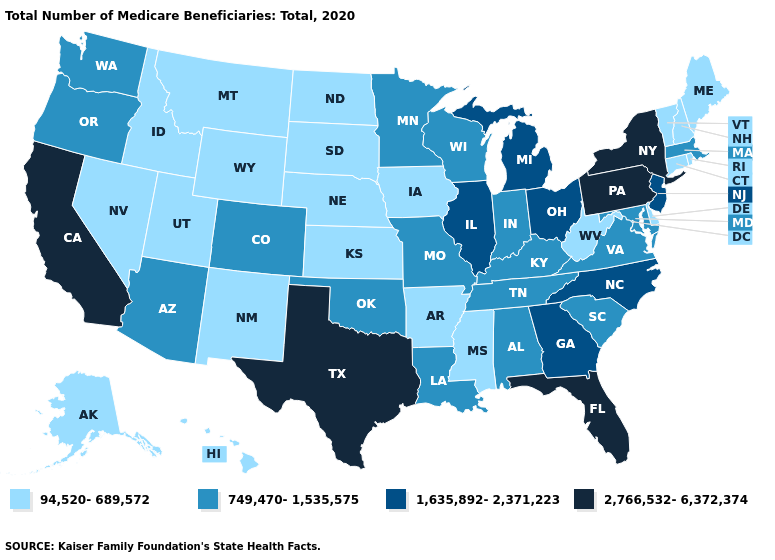What is the value of Arizona?
Quick response, please. 749,470-1,535,575. What is the lowest value in the Northeast?
Be succinct. 94,520-689,572. What is the value of Kentucky?
Short answer required. 749,470-1,535,575. What is the value of North Carolina?
Give a very brief answer. 1,635,892-2,371,223. What is the lowest value in the USA?
Be succinct. 94,520-689,572. What is the value of Connecticut?
Concise answer only. 94,520-689,572. Does Texas have the highest value in the USA?
Answer briefly. Yes. Does West Virginia have the lowest value in the USA?
Be succinct. Yes. Does Oregon have the same value as Washington?
Be succinct. Yes. Does the first symbol in the legend represent the smallest category?
Short answer required. Yes. Does North Carolina have the same value as Ohio?
Be succinct. Yes. What is the lowest value in the USA?
Write a very short answer. 94,520-689,572. Is the legend a continuous bar?
Be succinct. No. Name the states that have a value in the range 749,470-1,535,575?
Concise answer only. Alabama, Arizona, Colorado, Indiana, Kentucky, Louisiana, Maryland, Massachusetts, Minnesota, Missouri, Oklahoma, Oregon, South Carolina, Tennessee, Virginia, Washington, Wisconsin. 